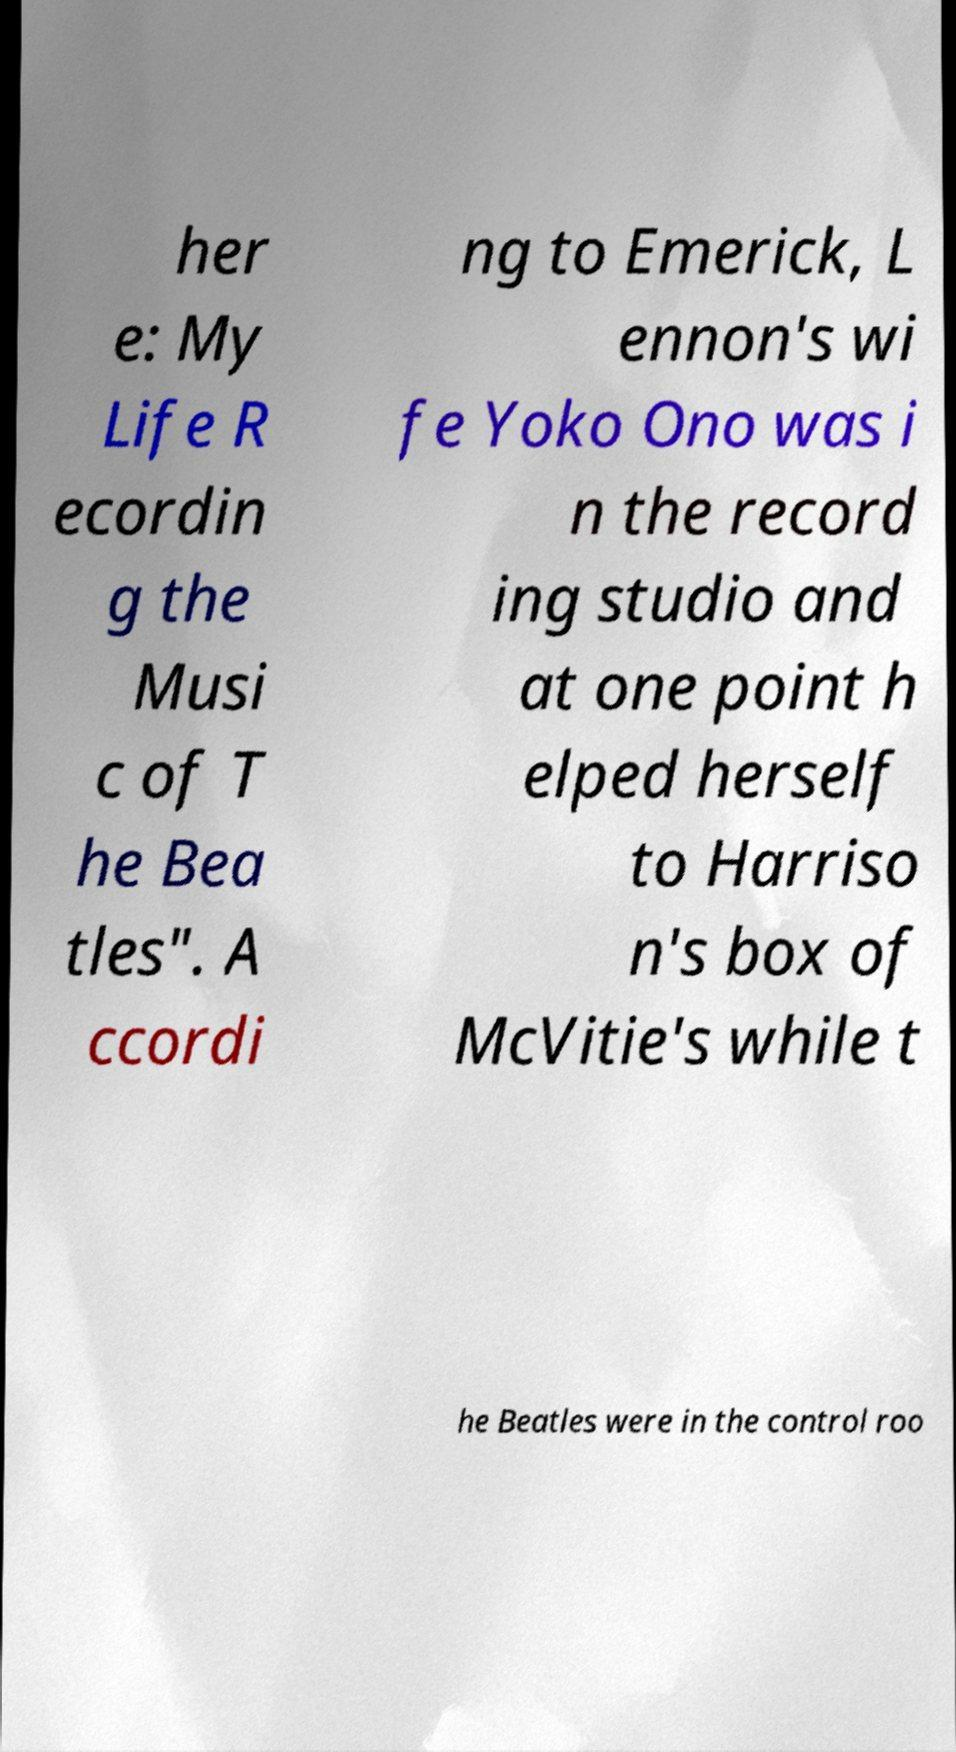Please read and relay the text visible in this image. What does it say? her e: My Life R ecordin g the Musi c of T he Bea tles". A ccordi ng to Emerick, L ennon's wi fe Yoko Ono was i n the record ing studio and at one point h elped herself to Harriso n's box of McVitie's while t he Beatles were in the control roo 